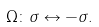<formula> <loc_0><loc_0><loc_500><loc_500>\Omega \colon \sigma \leftrightarrow - \sigma .</formula> 